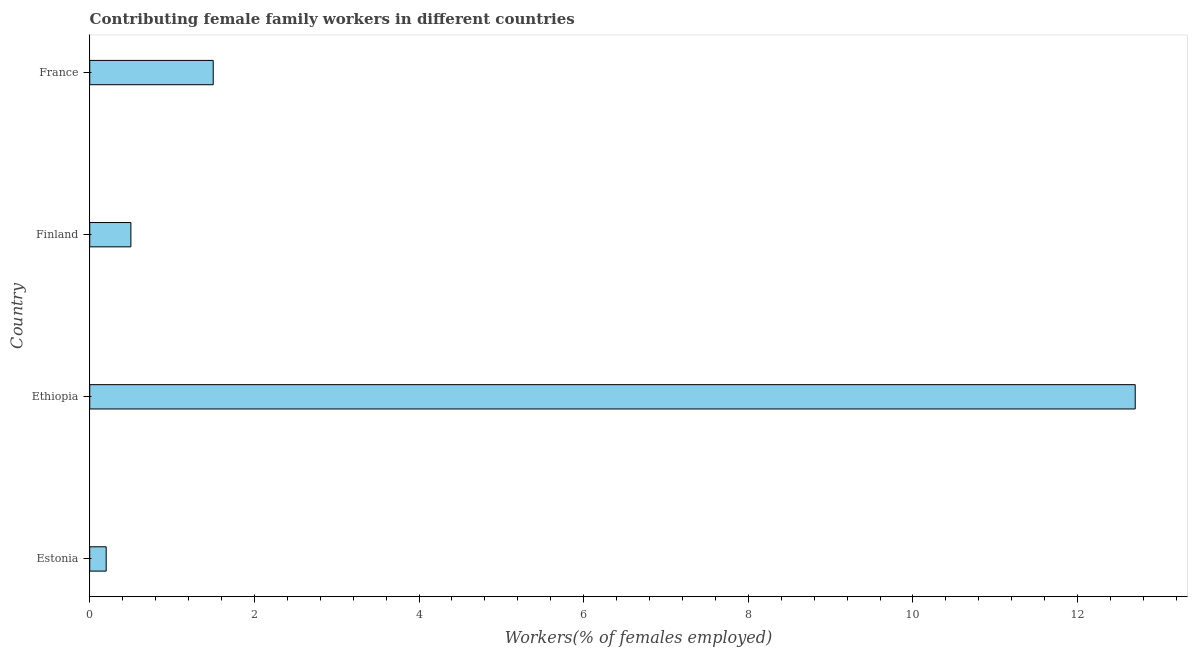Does the graph contain any zero values?
Offer a terse response. No. What is the title of the graph?
Ensure brevity in your answer.  Contributing female family workers in different countries. What is the label or title of the X-axis?
Give a very brief answer. Workers(% of females employed). What is the contributing female family workers in France?
Provide a short and direct response. 1.5. Across all countries, what is the maximum contributing female family workers?
Your response must be concise. 12.7. Across all countries, what is the minimum contributing female family workers?
Offer a terse response. 0.2. In which country was the contributing female family workers maximum?
Your answer should be very brief. Ethiopia. In which country was the contributing female family workers minimum?
Offer a very short reply. Estonia. What is the sum of the contributing female family workers?
Ensure brevity in your answer.  14.9. What is the difference between the contributing female family workers in Ethiopia and Finland?
Your response must be concise. 12.2. What is the average contributing female family workers per country?
Keep it short and to the point. 3.73. What is the ratio of the contributing female family workers in Estonia to that in Finland?
Your answer should be compact. 0.4. Is the contributing female family workers in Estonia less than that in France?
Offer a terse response. Yes. Is the difference between the contributing female family workers in Estonia and France greater than the difference between any two countries?
Ensure brevity in your answer.  No. What is the difference between the highest and the second highest contributing female family workers?
Your response must be concise. 11.2. Is the sum of the contributing female family workers in Finland and France greater than the maximum contributing female family workers across all countries?
Your answer should be very brief. No. What is the difference between the highest and the lowest contributing female family workers?
Offer a terse response. 12.5. Are all the bars in the graph horizontal?
Your answer should be compact. Yes. How many countries are there in the graph?
Provide a short and direct response. 4. What is the difference between two consecutive major ticks on the X-axis?
Offer a terse response. 2. Are the values on the major ticks of X-axis written in scientific E-notation?
Make the answer very short. No. What is the Workers(% of females employed) in Estonia?
Provide a short and direct response. 0.2. What is the Workers(% of females employed) in Ethiopia?
Your answer should be compact. 12.7. What is the Workers(% of females employed) of Finland?
Offer a terse response. 0.5. What is the difference between the Workers(% of females employed) in Estonia and Ethiopia?
Provide a succinct answer. -12.5. What is the difference between the Workers(% of females employed) in Estonia and France?
Ensure brevity in your answer.  -1.3. What is the difference between the Workers(% of females employed) in Ethiopia and France?
Make the answer very short. 11.2. What is the difference between the Workers(% of females employed) in Finland and France?
Make the answer very short. -1. What is the ratio of the Workers(% of females employed) in Estonia to that in Ethiopia?
Offer a terse response. 0.02. What is the ratio of the Workers(% of females employed) in Estonia to that in Finland?
Ensure brevity in your answer.  0.4. What is the ratio of the Workers(% of females employed) in Estonia to that in France?
Make the answer very short. 0.13. What is the ratio of the Workers(% of females employed) in Ethiopia to that in Finland?
Provide a succinct answer. 25.4. What is the ratio of the Workers(% of females employed) in Ethiopia to that in France?
Provide a short and direct response. 8.47. What is the ratio of the Workers(% of females employed) in Finland to that in France?
Provide a succinct answer. 0.33. 